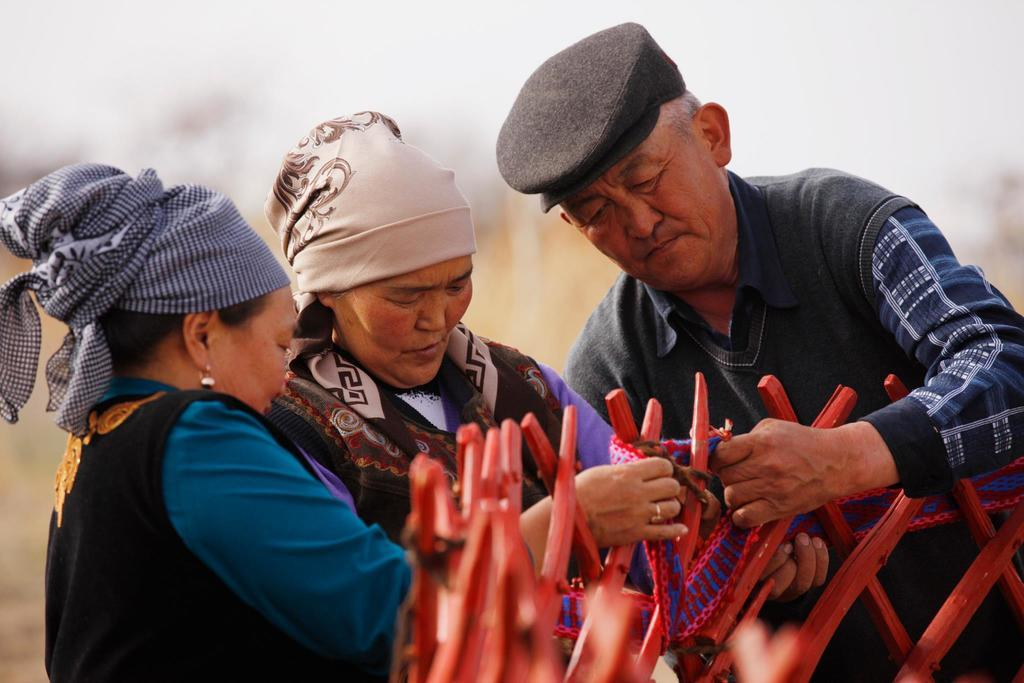How many people are present in the image? There is a man and two women in the image. What are the persons holding in the image? The persons are holding woolen cloth in the image. How is the woolen cloth attached to the wooden sticks? The woolen cloth is tied to wooden sticks in the image. Can you describe the background of the image? The background of the image is blurred. What type of earth can be seen in the image? There is no earth visible in the image; it features people holding woolen cloth tied to wooden sticks. 